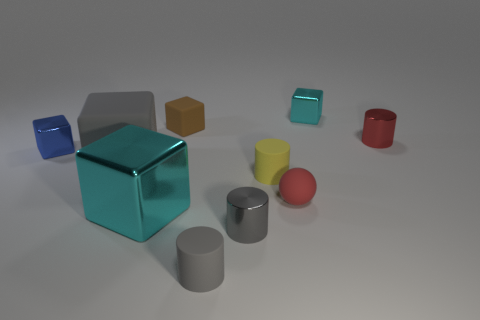Does the large gray thing have the same material as the small sphere?
Provide a short and direct response. Yes. How many other objects are there of the same shape as the large gray rubber object?
Give a very brief answer. 4. There is a cube to the left of the rubber cube left of the big object in front of the yellow matte thing; what color is it?
Your response must be concise. Blue. Does the small metal object that is in front of the yellow rubber cylinder have the same shape as the tiny brown rubber object?
Offer a very short reply. No. What number of large things are there?
Ensure brevity in your answer.  2. How many brown matte blocks are the same size as the blue thing?
Give a very brief answer. 1. What material is the yellow thing?
Keep it short and to the point. Rubber. Do the sphere and the tiny metallic cylinder that is right of the tiny gray shiny cylinder have the same color?
Your answer should be very brief. Yes. Are there any other things that are the same size as the gray rubber cylinder?
Keep it short and to the point. Yes. How big is the metallic object that is both left of the tiny red cylinder and behind the blue object?
Make the answer very short. Small. 